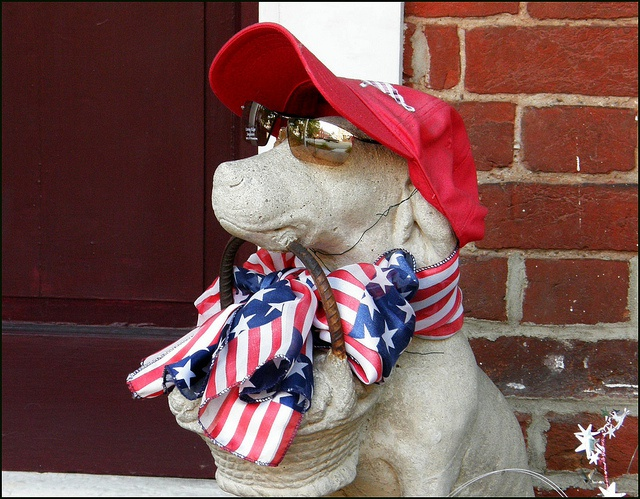Describe the objects in this image and their specific colors. I can see a dog in black, darkgray, lightgray, and gray tones in this image. 